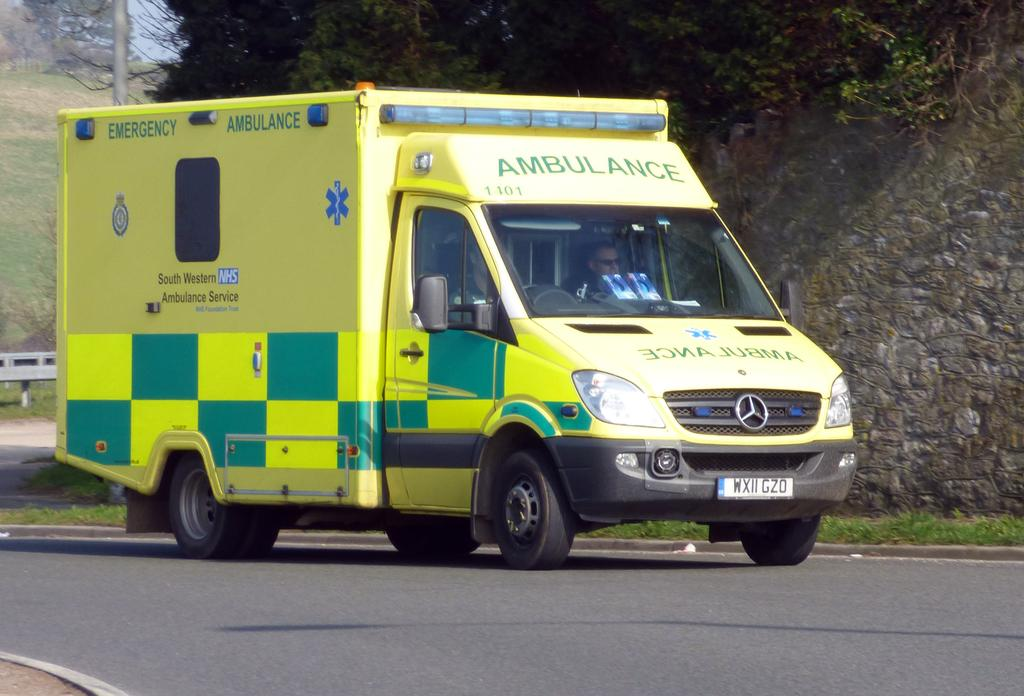What is the main subject of the image? There is a vehicle in the image. Are there any people in the vehicle? Yes, there are people inside the vehicle. Where is the vehicle located? The vehicle is on the road. What can be seen in the background of the image? There is a wall, trees, a pole, a fence, grass, and the sky visible in the background of the image. What type of scientific development is being discussed by the people inside the vehicle? There is no indication in the image that the people inside the vehicle are discussing any scientific development. 